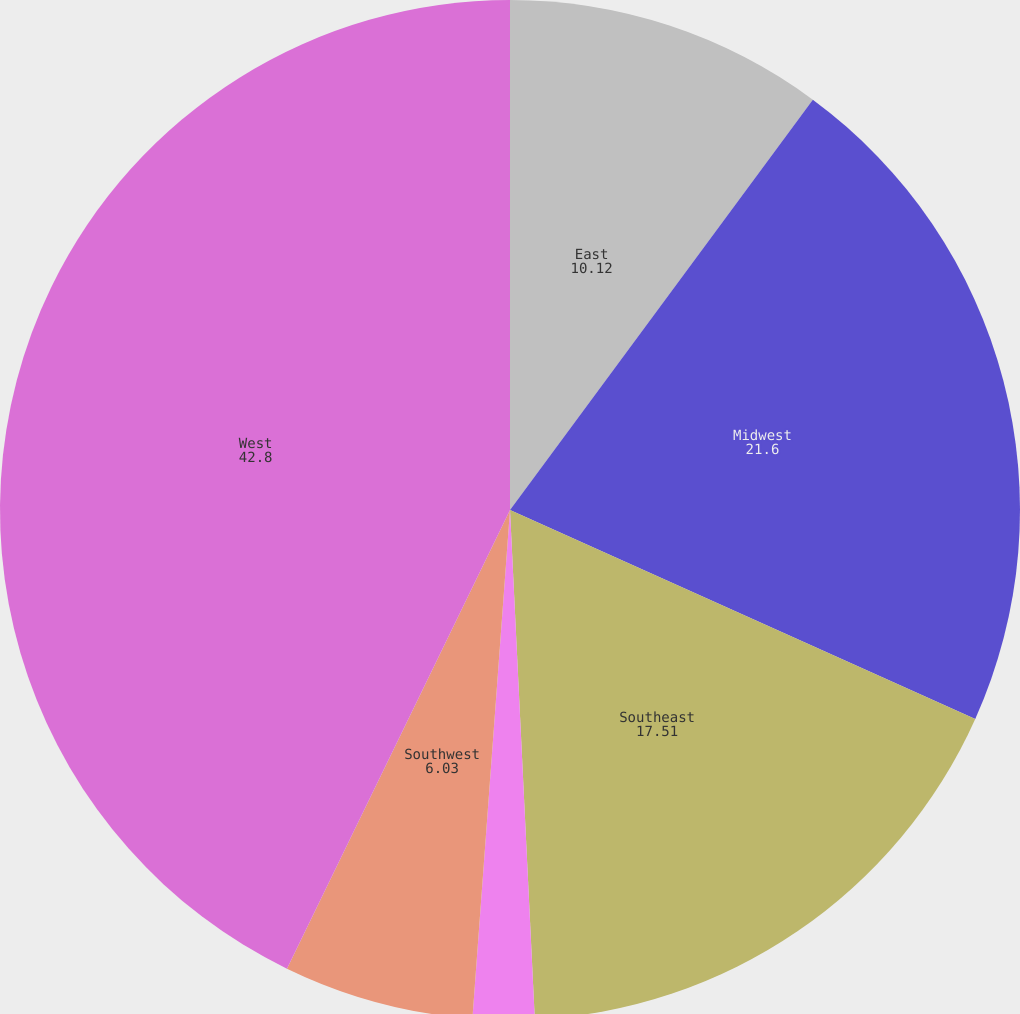Convert chart. <chart><loc_0><loc_0><loc_500><loc_500><pie_chart><fcel>East<fcel>Midwest<fcel>Southeast<fcel>South Central<fcel>Southwest<fcel>West<nl><fcel>10.12%<fcel>21.6%<fcel>17.51%<fcel>1.95%<fcel>6.03%<fcel>42.8%<nl></chart> 